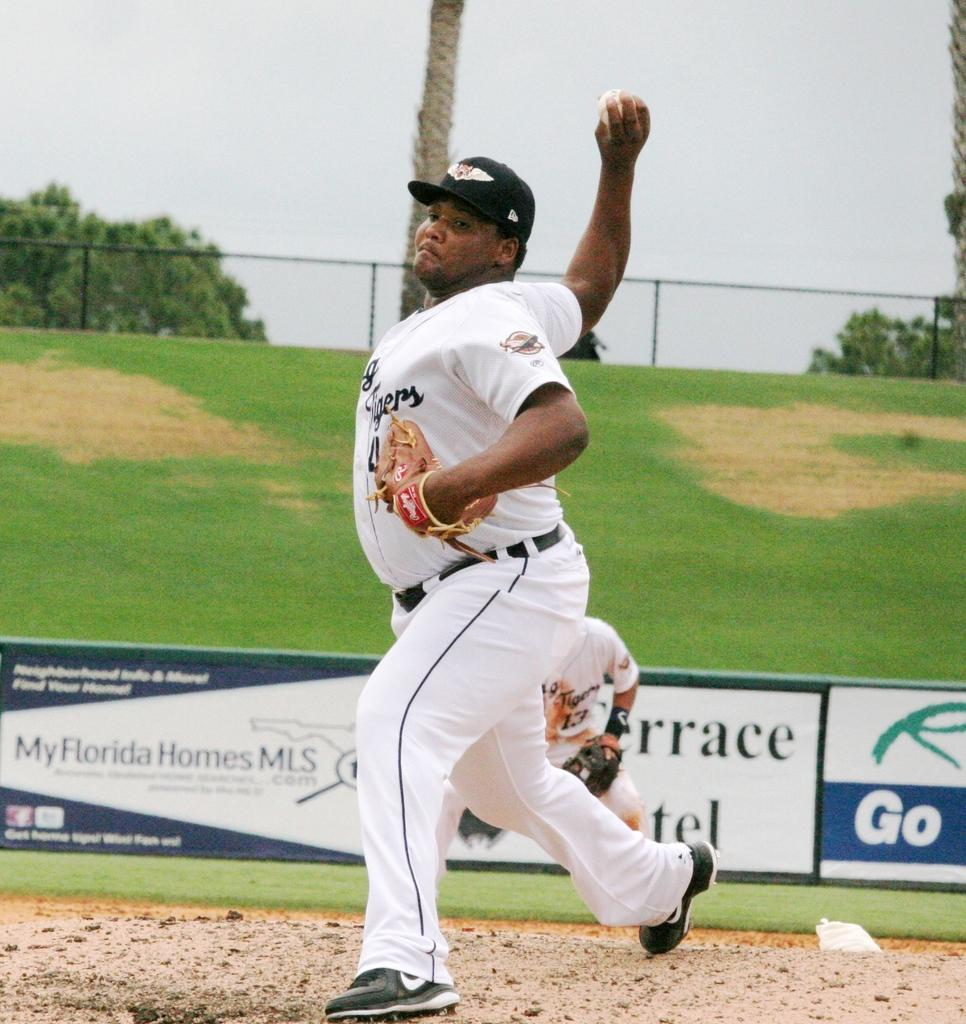<image>
Present a compact description of the photo's key features. The man pitching the ball has the word Tigers on his top. 